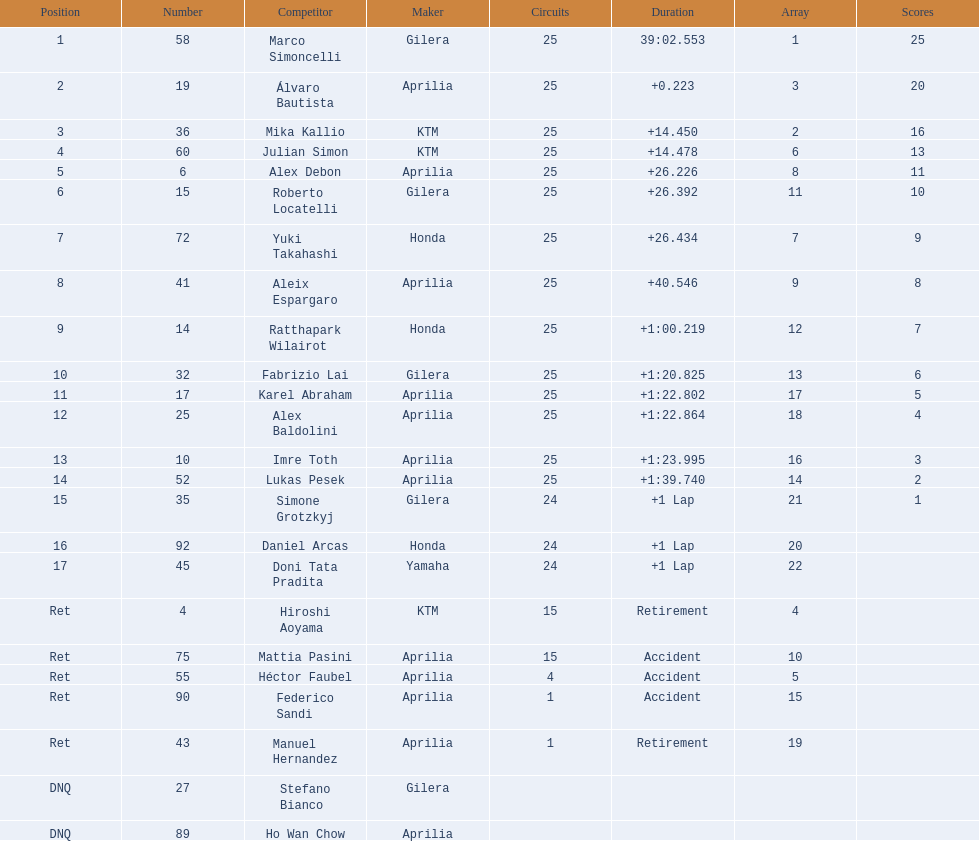How many laps did hiroshi aoyama perform? 15. How many laps did marco simoncelli perform? 25. Who performed more laps out of hiroshi aoyama and marco 
simoncelli? Marco Simoncelli. 